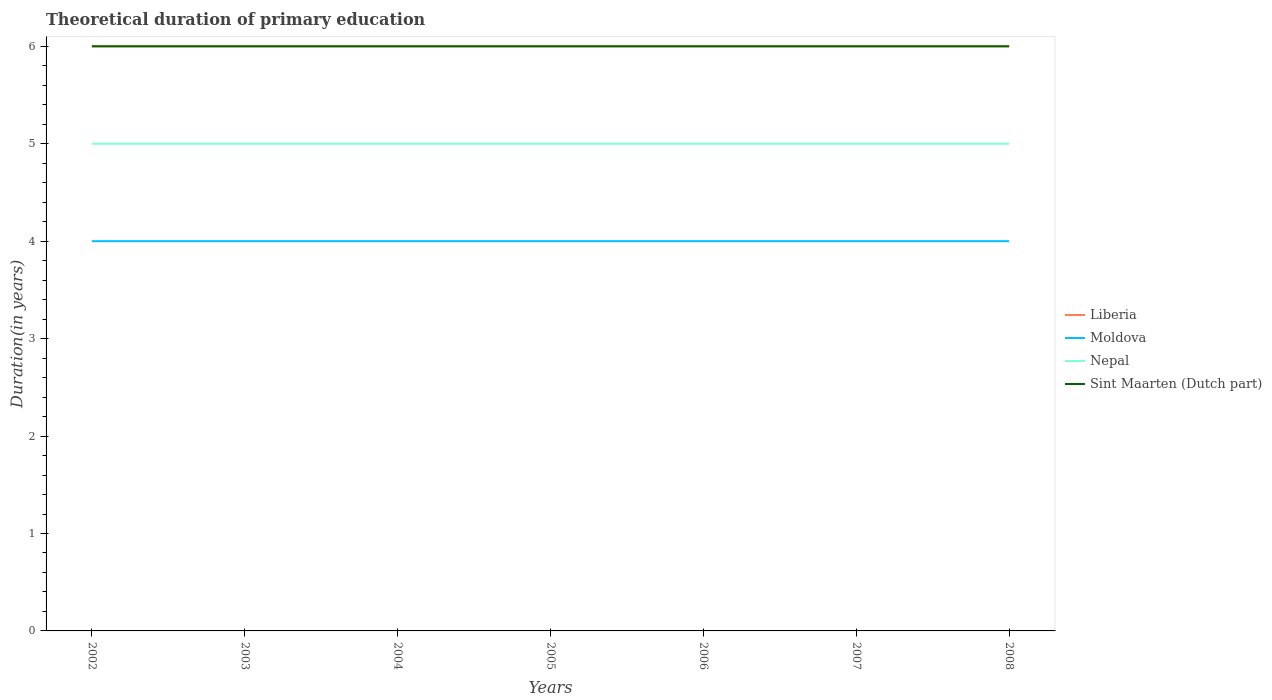Is the number of lines equal to the number of legend labels?
Ensure brevity in your answer.  Yes. Across all years, what is the maximum total theoretical duration of primary education in Moldova?
Keep it short and to the point. 4. In which year was the total theoretical duration of primary education in Nepal maximum?
Offer a terse response. 2002. What is the total total theoretical duration of primary education in Sint Maarten (Dutch part) in the graph?
Your answer should be compact. 0. What is the difference between the highest and the second highest total theoretical duration of primary education in Moldova?
Provide a short and direct response. 0. What is the difference between the highest and the lowest total theoretical duration of primary education in Moldova?
Offer a very short reply. 0. How many lines are there?
Provide a short and direct response. 4. How many legend labels are there?
Ensure brevity in your answer.  4. How are the legend labels stacked?
Keep it short and to the point. Vertical. What is the title of the graph?
Offer a very short reply. Theoretical duration of primary education. What is the label or title of the Y-axis?
Provide a succinct answer. Duration(in years). What is the Duration(in years) of Liberia in 2002?
Give a very brief answer. 6. What is the Duration(in years) of Sint Maarten (Dutch part) in 2002?
Ensure brevity in your answer.  6. What is the Duration(in years) in Nepal in 2003?
Keep it short and to the point. 5. What is the Duration(in years) of Sint Maarten (Dutch part) in 2003?
Ensure brevity in your answer.  6. What is the Duration(in years) in Liberia in 2004?
Make the answer very short. 6. What is the Duration(in years) in Moldova in 2004?
Give a very brief answer. 4. What is the Duration(in years) of Nepal in 2004?
Your response must be concise. 5. What is the Duration(in years) in Sint Maarten (Dutch part) in 2005?
Ensure brevity in your answer.  6. What is the Duration(in years) of Moldova in 2006?
Keep it short and to the point. 4. What is the Duration(in years) of Sint Maarten (Dutch part) in 2006?
Provide a succinct answer. 6. What is the Duration(in years) in Liberia in 2007?
Provide a succinct answer. 6. What is the Duration(in years) in Nepal in 2007?
Make the answer very short. 5. What is the Duration(in years) of Liberia in 2008?
Give a very brief answer. 6. What is the Duration(in years) in Moldova in 2008?
Provide a succinct answer. 4. What is the Duration(in years) of Sint Maarten (Dutch part) in 2008?
Provide a succinct answer. 6. Across all years, what is the maximum Duration(in years) of Liberia?
Provide a short and direct response. 6. Across all years, what is the maximum Duration(in years) of Moldova?
Make the answer very short. 4. What is the total Duration(in years) of Moldova in the graph?
Your answer should be very brief. 28. What is the total Duration(in years) in Nepal in the graph?
Give a very brief answer. 35. What is the total Duration(in years) of Sint Maarten (Dutch part) in the graph?
Your answer should be very brief. 42. What is the difference between the Duration(in years) of Liberia in 2002 and that in 2003?
Make the answer very short. 0. What is the difference between the Duration(in years) in Moldova in 2002 and that in 2003?
Provide a short and direct response. 0. What is the difference between the Duration(in years) in Nepal in 2002 and that in 2003?
Offer a very short reply. 0. What is the difference between the Duration(in years) of Nepal in 2002 and that in 2004?
Give a very brief answer. 0. What is the difference between the Duration(in years) in Sint Maarten (Dutch part) in 2002 and that in 2004?
Your answer should be very brief. 0. What is the difference between the Duration(in years) of Nepal in 2002 and that in 2005?
Your answer should be very brief. 0. What is the difference between the Duration(in years) of Sint Maarten (Dutch part) in 2002 and that in 2005?
Give a very brief answer. 0. What is the difference between the Duration(in years) of Moldova in 2002 and that in 2006?
Make the answer very short. 0. What is the difference between the Duration(in years) of Nepal in 2002 and that in 2006?
Your response must be concise. 0. What is the difference between the Duration(in years) of Sint Maarten (Dutch part) in 2002 and that in 2006?
Offer a terse response. 0. What is the difference between the Duration(in years) in Liberia in 2002 and that in 2007?
Your answer should be very brief. 0. What is the difference between the Duration(in years) in Nepal in 2002 and that in 2007?
Provide a short and direct response. 0. What is the difference between the Duration(in years) of Sint Maarten (Dutch part) in 2002 and that in 2007?
Provide a succinct answer. 0. What is the difference between the Duration(in years) of Liberia in 2002 and that in 2008?
Your answer should be very brief. 0. What is the difference between the Duration(in years) in Moldova in 2002 and that in 2008?
Provide a succinct answer. 0. What is the difference between the Duration(in years) of Nepal in 2002 and that in 2008?
Provide a short and direct response. 0. What is the difference between the Duration(in years) in Sint Maarten (Dutch part) in 2002 and that in 2008?
Make the answer very short. 0. What is the difference between the Duration(in years) of Liberia in 2003 and that in 2005?
Provide a succinct answer. 0. What is the difference between the Duration(in years) in Moldova in 2003 and that in 2005?
Offer a very short reply. 0. What is the difference between the Duration(in years) in Nepal in 2003 and that in 2005?
Provide a short and direct response. 0. What is the difference between the Duration(in years) in Sint Maarten (Dutch part) in 2003 and that in 2005?
Your response must be concise. 0. What is the difference between the Duration(in years) of Liberia in 2003 and that in 2008?
Ensure brevity in your answer.  0. What is the difference between the Duration(in years) of Nepal in 2003 and that in 2008?
Provide a succinct answer. 0. What is the difference between the Duration(in years) in Sint Maarten (Dutch part) in 2003 and that in 2008?
Offer a very short reply. 0. What is the difference between the Duration(in years) in Liberia in 2004 and that in 2005?
Offer a very short reply. 0. What is the difference between the Duration(in years) in Nepal in 2004 and that in 2005?
Your answer should be compact. 0. What is the difference between the Duration(in years) of Liberia in 2004 and that in 2006?
Your answer should be compact. 0. What is the difference between the Duration(in years) of Moldova in 2004 and that in 2006?
Provide a succinct answer. 0. What is the difference between the Duration(in years) in Nepal in 2004 and that in 2007?
Provide a short and direct response. 0. What is the difference between the Duration(in years) in Liberia in 2004 and that in 2008?
Your answer should be very brief. 0. What is the difference between the Duration(in years) in Moldova in 2004 and that in 2008?
Offer a terse response. 0. What is the difference between the Duration(in years) in Nepal in 2004 and that in 2008?
Offer a terse response. 0. What is the difference between the Duration(in years) of Sint Maarten (Dutch part) in 2004 and that in 2008?
Your response must be concise. 0. What is the difference between the Duration(in years) of Liberia in 2005 and that in 2006?
Keep it short and to the point. 0. What is the difference between the Duration(in years) of Moldova in 2005 and that in 2006?
Provide a short and direct response. 0. What is the difference between the Duration(in years) of Nepal in 2005 and that in 2006?
Make the answer very short. 0. What is the difference between the Duration(in years) of Sint Maarten (Dutch part) in 2005 and that in 2006?
Ensure brevity in your answer.  0. What is the difference between the Duration(in years) in Liberia in 2005 and that in 2007?
Your answer should be very brief. 0. What is the difference between the Duration(in years) of Sint Maarten (Dutch part) in 2005 and that in 2007?
Your response must be concise. 0. What is the difference between the Duration(in years) in Liberia in 2005 and that in 2008?
Your answer should be very brief. 0. What is the difference between the Duration(in years) in Moldova in 2005 and that in 2008?
Offer a very short reply. 0. What is the difference between the Duration(in years) of Nepal in 2006 and that in 2007?
Your answer should be compact. 0. What is the difference between the Duration(in years) in Moldova in 2006 and that in 2008?
Keep it short and to the point. 0. What is the difference between the Duration(in years) of Liberia in 2007 and that in 2008?
Your answer should be compact. 0. What is the difference between the Duration(in years) in Moldova in 2007 and that in 2008?
Ensure brevity in your answer.  0. What is the difference between the Duration(in years) in Nepal in 2007 and that in 2008?
Your response must be concise. 0. What is the difference between the Duration(in years) of Sint Maarten (Dutch part) in 2007 and that in 2008?
Offer a terse response. 0. What is the difference between the Duration(in years) of Liberia in 2002 and the Duration(in years) of Nepal in 2003?
Your response must be concise. 1. What is the difference between the Duration(in years) in Nepal in 2002 and the Duration(in years) in Sint Maarten (Dutch part) in 2003?
Offer a terse response. -1. What is the difference between the Duration(in years) of Liberia in 2002 and the Duration(in years) of Nepal in 2004?
Your response must be concise. 1. What is the difference between the Duration(in years) in Liberia in 2002 and the Duration(in years) in Sint Maarten (Dutch part) in 2004?
Give a very brief answer. 0. What is the difference between the Duration(in years) of Liberia in 2002 and the Duration(in years) of Moldova in 2005?
Keep it short and to the point. 2. What is the difference between the Duration(in years) of Liberia in 2002 and the Duration(in years) of Nepal in 2005?
Keep it short and to the point. 1. What is the difference between the Duration(in years) of Moldova in 2002 and the Duration(in years) of Sint Maarten (Dutch part) in 2005?
Your answer should be very brief. -2. What is the difference between the Duration(in years) in Nepal in 2002 and the Duration(in years) in Sint Maarten (Dutch part) in 2005?
Make the answer very short. -1. What is the difference between the Duration(in years) of Liberia in 2002 and the Duration(in years) of Nepal in 2006?
Give a very brief answer. 1. What is the difference between the Duration(in years) in Moldova in 2002 and the Duration(in years) in Nepal in 2006?
Make the answer very short. -1. What is the difference between the Duration(in years) in Nepal in 2002 and the Duration(in years) in Sint Maarten (Dutch part) in 2006?
Your answer should be very brief. -1. What is the difference between the Duration(in years) in Liberia in 2002 and the Duration(in years) in Moldova in 2007?
Ensure brevity in your answer.  2. What is the difference between the Duration(in years) in Liberia in 2002 and the Duration(in years) in Nepal in 2007?
Provide a succinct answer. 1. What is the difference between the Duration(in years) in Liberia in 2002 and the Duration(in years) in Sint Maarten (Dutch part) in 2007?
Provide a short and direct response. 0. What is the difference between the Duration(in years) in Nepal in 2002 and the Duration(in years) in Sint Maarten (Dutch part) in 2007?
Keep it short and to the point. -1. What is the difference between the Duration(in years) of Liberia in 2002 and the Duration(in years) of Sint Maarten (Dutch part) in 2008?
Your answer should be compact. 0. What is the difference between the Duration(in years) of Moldova in 2002 and the Duration(in years) of Nepal in 2008?
Give a very brief answer. -1. What is the difference between the Duration(in years) in Moldova in 2002 and the Duration(in years) in Sint Maarten (Dutch part) in 2008?
Your answer should be compact. -2. What is the difference between the Duration(in years) in Liberia in 2003 and the Duration(in years) in Sint Maarten (Dutch part) in 2004?
Make the answer very short. 0. What is the difference between the Duration(in years) of Nepal in 2003 and the Duration(in years) of Sint Maarten (Dutch part) in 2004?
Offer a terse response. -1. What is the difference between the Duration(in years) in Liberia in 2003 and the Duration(in years) in Sint Maarten (Dutch part) in 2005?
Offer a very short reply. 0. What is the difference between the Duration(in years) in Moldova in 2003 and the Duration(in years) in Nepal in 2005?
Provide a succinct answer. -1. What is the difference between the Duration(in years) in Liberia in 2003 and the Duration(in years) in Nepal in 2007?
Keep it short and to the point. 1. What is the difference between the Duration(in years) in Nepal in 2003 and the Duration(in years) in Sint Maarten (Dutch part) in 2007?
Make the answer very short. -1. What is the difference between the Duration(in years) of Liberia in 2003 and the Duration(in years) of Moldova in 2008?
Offer a very short reply. 2. What is the difference between the Duration(in years) in Liberia in 2003 and the Duration(in years) in Sint Maarten (Dutch part) in 2008?
Provide a succinct answer. 0. What is the difference between the Duration(in years) in Moldova in 2003 and the Duration(in years) in Nepal in 2008?
Keep it short and to the point. -1. What is the difference between the Duration(in years) of Moldova in 2003 and the Duration(in years) of Sint Maarten (Dutch part) in 2008?
Make the answer very short. -2. What is the difference between the Duration(in years) in Nepal in 2003 and the Duration(in years) in Sint Maarten (Dutch part) in 2008?
Offer a terse response. -1. What is the difference between the Duration(in years) in Liberia in 2004 and the Duration(in years) in Nepal in 2005?
Keep it short and to the point. 1. What is the difference between the Duration(in years) in Moldova in 2004 and the Duration(in years) in Nepal in 2005?
Ensure brevity in your answer.  -1. What is the difference between the Duration(in years) in Moldova in 2004 and the Duration(in years) in Sint Maarten (Dutch part) in 2005?
Give a very brief answer. -2. What is the difference between the Duration(in years) in Nepal in 2004 and the Duration(in years) in Sint Maarten (Dutch part) in 2005?
Ensure brevity in your answer.  -1. What is the difference between the Duration(in years) of Liberia in 2004 and the Duration(in years) of Moldova in 2006?
Give a very brief answer. 2. What is the difference between the Duration(in years) in Moldova in 2004 and the Duration(in years) in Sint Maarten (Dutch part) in 2006?
Ensure brevity in your answer.  -2. What is the difference between the Duration(in years) in Liberia in 2004 and the Duration(in years) in Moldova in 2007?
Offer a very short reply. 2. What is the difference between the Duration(in years) of Moldova in 2004 and the Duration(in years) of Nepal in 2007?
Give a very brief answer. -1. What is the difference between the Duration(in years) in Nepal in 2004 and the Duration(in years) in Sint Maarten (Dutch part) in 2007?
Ensure brevity in your answer.  -1. What is the difference between the Duration(in years) in Liberia in 2004 and the Duration(in years) in Moldova in 2008?
Keep it short and to the point. 2. What is the difference between the Duration(in years) of Liberia in 2004 and the Duration(in years) of Nepal in 2008?
Offer a very short reply. 1. What is the difference between the Duration(in years) of Liberia in 2005 and the Duration(in years) of Sint Maarten (Dutch part) in 2006?
Your response must be concise. 0. What is the difference between the Duration(in years) of Nepal in 2005 and the Duration(in years) of Sint Maarten (Dutch part) in 2006?
Provide a succinct answer. -1. What is the difference between the Duration(in years) in Liberia in 2005 and the Duration(in years) in Nepal in 2007?
Your answer should be very brief. 1. What is the difference between the Duration(in years) in Liberia in 2005 and the Duration(in years) in Sint Maarten (Dutch part) in 2007?
Provide a succinct answer. 0. What is the difference between the Duration(in years) of Moldova in 2005 and the Duration(in years) of Sint Maarten (Dutch part) in 2007?
Keep it short and to the point. -2. What is the difference between the Duration(in years) of Nepal in 2005 and the Duration(in years) of Sint Maarten (Dutch part) in 2007?
Keep it short and to the point. -1. What is the difference between the Duration(in years) of Moldova in 2005 and the Duration(in years) of Nepal in 2008?
Provide a short and direct response. -1. What is the difference between the Duration(in years) in Liberia in 2006 and the Duration(in years) in Moldova in 2007?
Your response must be concise. 2. What is the difference between the Duration(in years) in Liberia in 2006 and the Duration(in years) in Sint Maarten (Dutch part) in 2007?
Provide a succinct answer. 0. What is the difference between the Duration(in years) of Moldova in 2006 and the Duration(in years) of Nepal in 2008?
Your response must be concise. -1. What is the difference between the Duration(in years) of Nepal in 2006 and the Duration(in years) of Sint Maarten (Dutch part) in 2008?
Offer a terse response. -1. What is the difference between the Duration(in years) of Liberia in 2007 and the Duration(in years) of Sint Maarten (Dutch part) in 2008?
Offer a terse response. 0. What is the difference between the Duration(in years) of Moldova in 2007 and the Duration(in years) of Nepal in 2008?
Provide a succinct answer. -1. What is the difference between the Duration(in years) of Nepal in 2007 and the Duration(in years) of Sint Maarten (Dutch part) in 2008?
Provide a succinct answer. -1. What is the average Duration(in years) in Liberia per year?
Ensure brevity in your answer.  6. What is the average Duration(in years) in Moldova per year?
Offer a terse response. 4. What is the average Duration(in years) of Nepal per year?
Give a very brief answer. 5. What is the average Duration(in years) in Sint Maarten (Dutch part) per year?
Provide a succinct answer. 6. In the year 2002, what is the difference between the Duration(in years) of Liberia and Duration(in years) of Moldova?
Offer a very short reply. 2. In the year 2002, what is the difference between the Duration(in years) in Liberia and Duration(in years) in Nepal?
Your answer should be very brief. 1. In the year 2002, what is the difference between the Duration(in years) of Liberia and Duration(in years) of Sint Maarten (Dutch part)?
Offer a very short reply. 0. In the year 2002, what is the difference between the Duration(in years) in Nepal and Duration(in years) in Sint Maarten (Dutch part)?
Make the answer very short. -1. In the year 2003, what is the difference between the Duration(in years) in Liberia and Duration(in years) in Nepal?
Ensure brevity in your answer.  1. In the year 2003, what is the difference between the Duration(in years) in Liberia and Duration(in years) in Sint Maarten (Dutch part)?
Provide a short and direct response. 0. In the year 2003, what is the difference between the Duration(in years) of Nepal and Duration(in years) of Sint Maarten (Dutch part)?
Provide a succinct answer. -1. In the year 2004, what is the difference between the Duration(in years) of Liberia and Duration(in years) of Sint Maarten (Dutch part)?
Your answer should be compact. 0. In the year 2005, what is the difference between the Duration(in years) in Nepal and Duration(in years) in Sint Maarten (Dutch part)?
Keep it short and to the point. -1. In the year 2006, what is the difference between the Duration(in years) in Liberia and Duration(in years) in Nepal?
Keep it short and to the point. 1. In the year 2006, what is the difference between the Duration(in years) of Moldova and Duration(in years) of Sint Maarten (Dutch part)?
Ensure brevity in your answer.  -2. In the year 2006, what is the difference between the Duration(in years) in Nepal and Duration(in years) in Sint Maarten (Dutch part)?
Your response must be concise. -1. In the year 2007, what is the difference between the Duration(in years) of Liberia and Duration(in years) of Moldova?
Provide a succinct answer. 2. In the year 2007, what is the difference between the Duration(in years) in Liberia and Duration(in years) in Sint Maarten (Dutch part)?
Ensure brevity in your answer.  0. In the year 2007, what is the difference between the Duration(in years) of Moldova and Duration(in years) of Sint Maarten (Dutch part)?
Your answer should be very brief. -2. In the year 2007, what is the difference between the Duration(in years) of Nepal and Duration(in years) of Sint Maarten (Dutch part)?
Give a very brief answer. -1. In the year 2008, what is the difference between the Duration(in years) in Liberia and Duration(in years) in Moldova?
Ensure brevity in your answer.  2. In the year 2008, what is the difference between the Duration(in years) in Moldova and Duration(in years) in Nepal?
Offer a very short reply. -1. In the year 2008, what is the difference between the Duration(in years) of Nepal and Duration(in years) of Sint Maarten (Dutch part)?
Offer a terse response. -1. What is the ratio of the Duration(in years) in Liberia in 2002 to that in 2003?
Offer a very short reply. 1. What is the ratio of the Duration(in years) in Nepal in 2002 to that in 2003?
Your answer should be compact. 1. What is the ratio of the Duration(in years) of Sint Maarten (Dutch part) in 2002 to that in 2003?
Your answer should be very brief. 1. What is the ratio of the Duration(in years) of Nepal in 2002 to that in 2004?
Offer a very short reply. 1. What is the ratio of the Duration(in years) in Moldova in 2002 to that in 2005?
Offer a very short reply. 1. What is the ratio of the Duration(in years) in Sint Maarten (Dutch part) in 2002 to that in 2005?
Ensure brevity in your answer.  1. What is the ratio of the Duration(in years) in Moldova in 2002 to that in 2006?
Provide a succinct answer. 1. What is the ratio of the Duration(in years) of Nepal in 2002 to that in 2006?
Ensure brevity in your answer.  1. What is the ratio of the Duration(in years) of Sint Maarten (Dutch part) in 2002 to that in 2006?
Provide a succinct answer. 1. What is the ratio of the Duration(in years) in Liberia in 2002 to that in 2007?
Provide a short and direct response. 1. What is the ratio of the Duration(in years) of Moldova in 2002 to that in 2007?
Offer a terse response. 1. What is the ratio of the Duration(in years) of Sint Maarten (Dutch part) in 2002 to that in 2007?
Offer a very short reply. 1. What is the ratio of the Duration(in years) in Liberia in 2002 to that in 2008?
Give a very brief answer. 1. What is the ratio of the Duration(in years) of Moldova in 2002 to that in 2008?
Provide a succinct answer. 1. What is the ratio of the Duration(in years) of Liberia in 2003 to that in 2004?
Keep it short and to the point. 1. What is the ratio of the Duration(in years) in Sint Maarten (Dutch part) in 2003 to that in 2004?
Your answer should be compact. 1. What is the ratio of the Duration(in years) of Sint Maarten (Dutch part) in 2003 to that in 2005?
Your answer should be very brief. 1. What is the ratio of the Duration(in years) of Liberia in 2003 to that in 2006?
Your response must be concise. 1. What is the ratio of the Duration(in years) in Sint Maarten (Dutch part) in 2003 to that in 2006?
Your answer should be very brief. 1. What is the ratio of the Duration(in years) in Liberia in 2003 to that in 2007?
Make the answer very short. 1. What is the ratio of the Duration(in years) in Moldova in 2003 to that in 2007?
Keep it short and to the point. 1. What is the ratio of the Duration(in years) of Nepal in 2003 to that in 2007?
Give a very brief answer. 1. What is the ratio of the Duration(in years) in Sint Maarten (Dutch part) in 2003 to that in 2007?
Make the answer very short. 1. What is the ratio of the Duration(in years) of Liberia in 2003 to that in 2008?
Make the answer very short. 1. What is the ratio of the Duration(in years) in Nepal in 2003 to that in 2008?
Provide a succinct answer. 1. What is the ratio of the Duration(in years) of Sint Maarten (Dutch part) in 2003 to that in 2008?
Provide a succinct answer. 1. What is the ratio of the Duration(in years) of Moldova in 2004 to that in 2005?
Provide a succinct answer. 1. What is the ratio of the Duration(in years) in Nepal in 2004 to that in 2005?
Keep it short and to the point. 1. What is the ratio of the Duration(in years) of Moldova in 2004 to that in 2006?
Ensure brevity in your answer.  1. What is the ratio of the Duration(in years) in Nepal in 2004 to that in 2006?
Provide a succinct answer. 1. What is the ratio of the Duration(in years) of Sint Maarten (Dutch part) in 2004 to that in 2006?
Make the answer very short. 1. What is the ratio of the Duration(in years) in Liberia in 2004 to that in 2007?
Ensure brevity in your answer.  1. What is the ratio of the Duration(in years) in Moldova in 2004 to that in 2007?
Your answer should be very brief. 1. What is the ratio of the Duration(in years) of Nepal in 2004 to that in 2007?
Your response must be concise. 1. What is the ratio of the Duration(in years) in Sint Maarten (Dutch part) in 2004 to that in 2007?
Offer a terse response. 1. What is the ratio of the Duration(in years) of Liberia in 2004 to that in 2008?
Offer a very short reply. 1. What is the ratio of the Duration(in years) in Sint Maarten (Dutch part) in 2004 to that in 2008?
Provide a succinct answer. 1. What is the ratio of the Duration(in years) in Liberia in 2005 to that in 2006?
Offer a terse response. 1. What is the ratio of the Duration(in years) of Sint Maarten (Dutch part) in 2005 to that in 2006?
Provide a succinct answer. 1. What is the ratio of the Duration(in years) in Moldova in 2005 to that in 2008?
Make the answer very short. 1. What is the ratio of the Duration(in years) of Nepal in 2005 to that in 2008?
Provide a succinct answer. 1. What is the ratio of the Duration(in years) in Sint Maarten (Dutch part) in 2005 to that in 2008?
Your answer should be compact. 1. What is the ratio of the Duration(in years) in Liberia in 2006 to that in 2007?
Offer a terse response. 1. What is the ratio of the Duration(in years) of Moldova in 2006 to that in 2007?
Offer a very short reply. 1. What is the ratio of the Duration(in years) in Nepal in 2006 to that in 2007?
Make the answer very short. 1. What is the ratio of the Duration(in years) of Sint Maarten (Dutch part) in 2006 to that in 2007?
Offer a very short reply. 1. What is the ratio of the Duration(in years) in Liberia in 2006 to that in 2008?
Offer a terse response. 1. What is the ratio of the Duration(in years) of Sint Maarten (Dutch part) in 2006 to that in 2008?
Provide a short and direct response. 1. What is the ratio of the Duration(in years) of Moldova in 2007 to that in 2008?
Provide a succinct answer. 1. What is the difference between the highest and the second highest Duration(in years) in Liberia?
Your response must be concise. 0. What is the difference between the highest and the second highest Duration(in years) of Moldova?
Your answer should be very brief. 0. What is the difference between the highest and the second highest Duration(in years) of Nepal?
Keep it short and to the point. 0. What is the difference between the highest and the lowest Duration(in years) in Liberia?
Ensure brevity in your answer.  0. What is the difference between the highest and the lowest Duration(in years) in Moldova?
Provide a short and direct response. 0. 